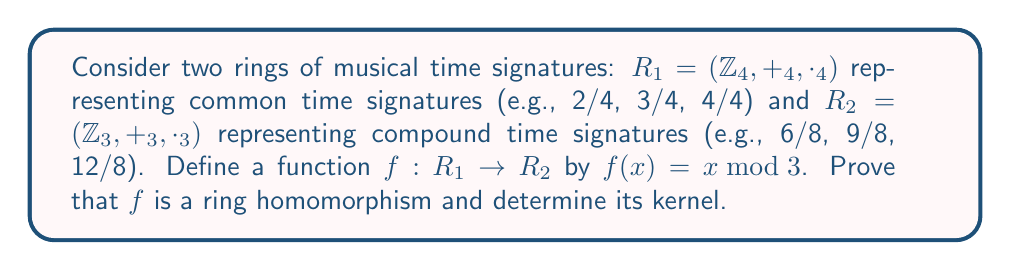Teach me how to tackle this problem. To prove that $f$ is a ring homomorphism and determine its kernel, we need to follow these steps:

1. Prove that $f$ preserves addition:
   For any $a, b \in R_1$, we need to show that $f(a +_4 b) = f(a) +_3 f(b)$
   
   $f(a +_4 b) = (a +_4 b) \mod 3 = ((a \mod 3) + (b \mod 3)) \mod 3 = f(a) +_3 f(b)$

2. Prove that $f$ preserves multiplication:
   For any $a, b \in R_1$, we need to show that $f(a \cdot_4 b) = f(a) \cdot_3 f(b)$
   
   $f(a \cdot_4 b) = (a \cdot_4 b) \mod 3 = ((a \mod 3) \cdot (b \mod 3)) \mod 3 = f(a) \cdot_3 f(b)$

3. Prove that $f$ maps the multiplicative identity:
   The multiplicative identity in $R_1$ is 1, and $f(1) = 1 \mod 3 = 1$, which is the multiplicative identity in $R_2$.

Since all three conditions are satisfied, $f$ is indeed a ring homomorphism.

4. Determine the kernel of $f$:
   The kernel of $f$ is the set of all elements in $R_1$ that map to the additive identity (0) in $R_2$.
   
   $\ker(f) = \{x \in R_1 | f(x) = 0\}$
   
   In this case, $\ker(f) = \{0, 3\}$ because:
   $f(0) = 0 \mod 3 = 0$
   $f(1) = 1 \mod 3 = 1$
   $f(2) = 2 \mod 3 = 2$
   $f(3) = 3 \mod 3 = 0$
Answer: $f$ is a ring homomorphism, and $\ker(f) = \{0, 3\}$. 